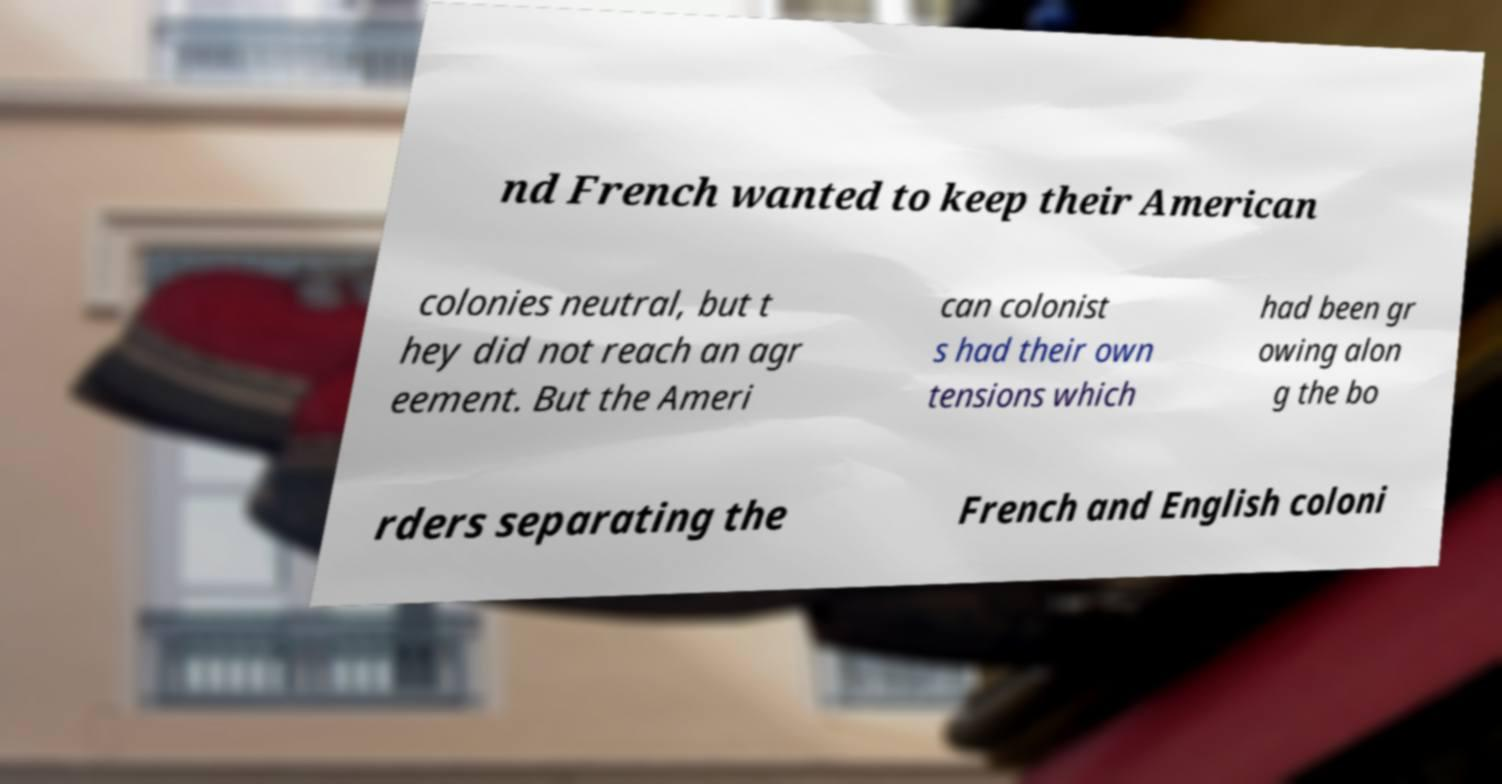I need the written content from this picture converted into text. Can you do that? nd French wanted to keep their American colonies neutral, but t hey did not reach an agr eement. But the Ameri can colonist s had their own tensions which had been gr owing alon g the bo rders separating the French and English coloni 